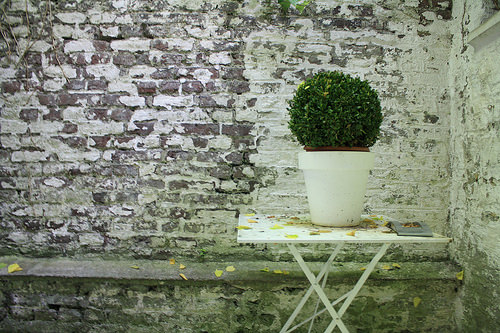<image>
Is there a plant above the table? Yes. The plant is positioned above the table in the vertical space, higher up in the scene. 